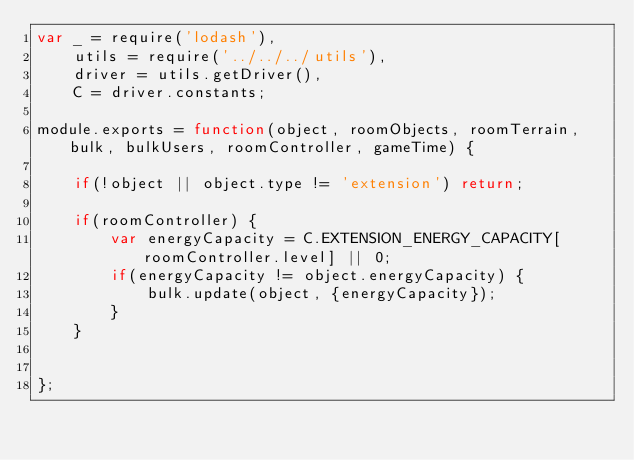Convert code to text. <code><loc_0><loc_0><loc_500><loc_500><_JavaScript_>var _ = require('lodash'),
    utils = require('../../../utils'),
    driver = utils.getDriver(),
    C = driver.constants;

module.exports = function(object, roomObjects, roomTerrain, bulk, bulkUsers, roomController, gameTime) {

    if(!object || object.type != 'extension') return;

    if(roomController) {
        var energyCapacity = C.EXTENSION_ENERGY_CAPACITY[roomController.level] || 0;
        if(energyCapacity != object.energyCapacity) {
            bulk.update(object, {energyCapacity});
        }
    }


};</code> 